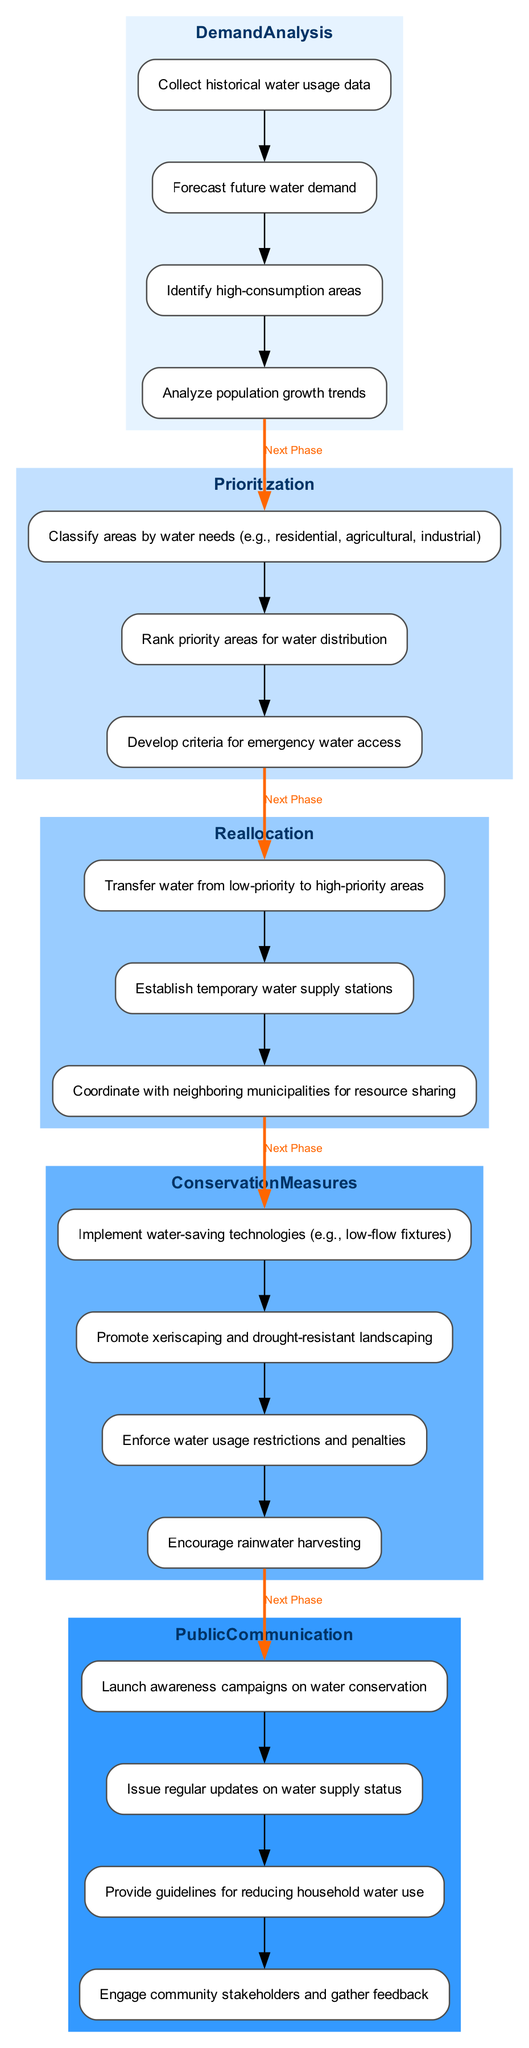What is the first step in the demand analysis phase? The first step in the demand analysis phase is to collect historical water usage data, as indicated in the diagram.
Answer: Collect historical water usage data How many activities are there in the conservation measures phase? The conservation measures phase contains four activities, as shown in the diagram.
Answer: Four Which activity follows 'Classify areas by water needs'? The activity that follows 'Classify areas by water needs' is 'Rank priority areas for water distribution', according to the flow of the diagram.
Answer: Rank priority areas for water distribution What is the last activity in the reallocation phase? The last activity in the reallocation phase is 'Coordinate with neighboring municipalities for resource sharing', which is clearly stated in the diagram.
Answer: Coordinate with neighboring municipalities for resource sharing What connects the 'Reallocation' phase to the 'Conservation Measures' phase? The connection from the 'Reallocation' phase to the 'Conservation Measures' phase is represented by the 'Next Phase' edge, indicating the flow between these two categories.
Answer: Next Phase How many total categories are there in the diagram? The diagram has five total categories, which include demand analysis, prioritization, reallocation, conservation measures, and public communication.
Answer: Five Which category comes after 'Prioritization'? The category that comes after 'Prioritization' is 'Reallocation', as per the sequence of categories in the diagram.
Answer: Reallocation What type of public communication activity focuses on community engagement? The activity that focuses on community engagement in public communication is 'Engage community stakeholders and gather feedback', as indicated in the diagram.
Answer: Engage community stakeholders and gather feedback What is the purpose of 'Develop criteria for emergency water access'? The purpose of 'Develop criteria for emergency water access' is to create a structured approach to prioritize critical needs in times of water shortages, according to the prioritization phase.
Answer: Prioritize critical needs in times of water shortages 